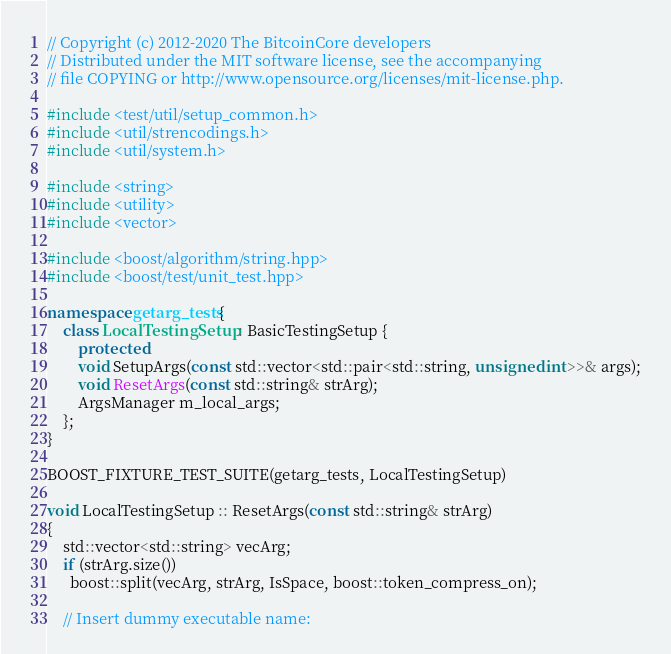Convert code to text. <code><loc_0><loc_0><loc_500><loc_500><_C++_>// Copyright (c) 2012-2020 The BitcoinCore developers
// Distributed under the MIT software license, see the accompanying
// file COPYING or http://www.opensource.org/licenses/mit-license.php.

#include <test/util/setup_common.h>
#include <util/strencodings.h>
#include <util/system.h>

#include <string>
#include <utility>
#include <vector>

#include <boost/algorithm/string.hpp>
#include <boost/test/unit_test.hpp>

namespace getarg_tests{
    class LocalTestingSetup : BasicTestingSetup {
        protected:
        void SetupArgs(const std::vector<std::pair<std::string, unsigned int>>& args);
        void ResetArgs(const std::string& strArg);
        ArgsManager m_local_args;
    };
}

BOOST_FIXTURE_TEST_SUITE(getarg_tests, LocalTestingSetup)

void LocalTestingSetup :: ResetArgs(const std::string& strArg)
{
    std::vector<std::string> vecArg;
    if (strArg.size())
      boost::split(vecArg, strArg, IsSpace, boost::token_compress_on);

    // Insert dummy executable name:</code> 